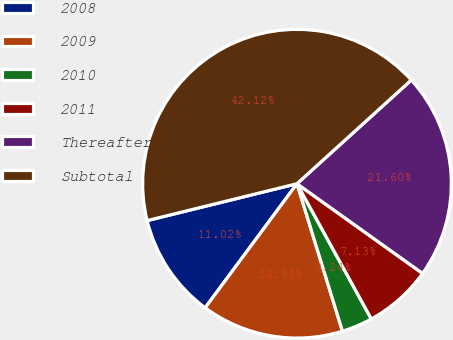Convert chart. <chart><loc_0><loc_0><loc_500><loc_500><pie_chart><fcel>2008<fcel>2009<fcel>2010<fcel>2011<fcel>Thereafter<fcel>Subtotal<nl><fcel>11.02%<fcel>14.9%<fcel>3.24%<fcel>7.13%<fcel>21.6%<fcel>42.12%<nl></chart> 